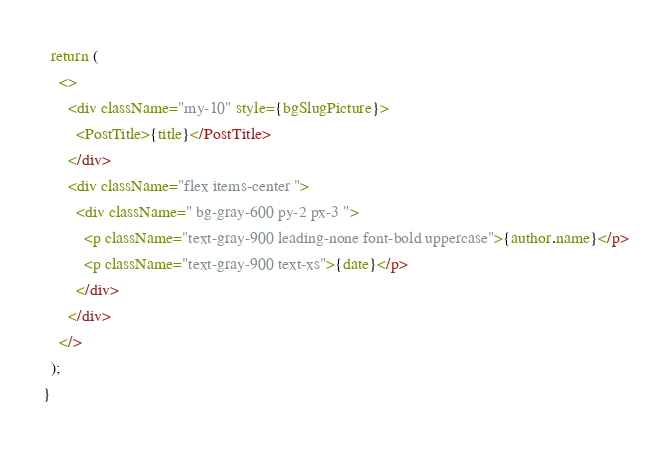<code> <loc_0><loc_0><loc_500><loc_500><_JavaScript_>  return (
    <>
      <div className="my-10" style={bgSlugPicture}>
        <PostTitle>{title}</PostTitle>
      </div>
      <div className="flex items-center ">
        <div className=" bg-gray-600 py-2 px-3 ">
          <p className="text-gray-900 leading-none font-bold uppercase">{author.name}</p>
          <p className="text-gray-900 text-xs">{date}</p>
        </div>
      </div>
    </>
  );
}
</code> 